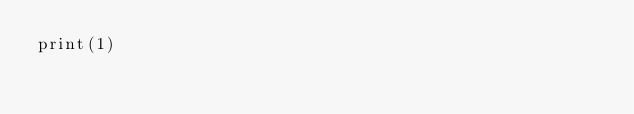Convert code to text. <code><loc_0><loc_0><loc_500><loc_500><_Python_>print(1)</code> 